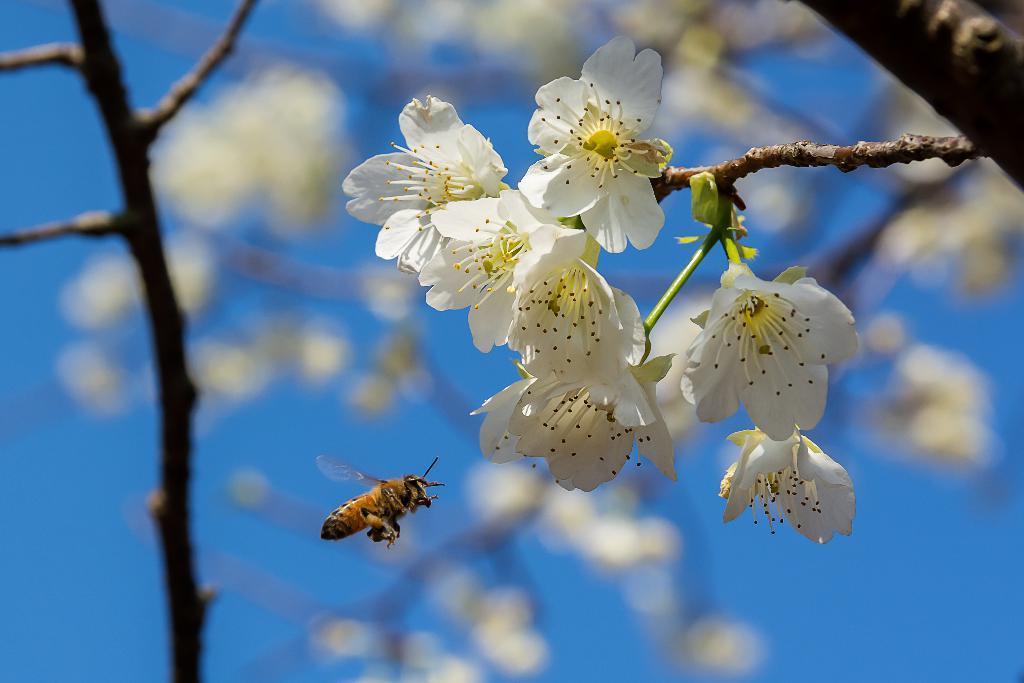Please provide a concise description of this image. In this image, I can see a bunch of flowers to a stem. I can see an insect flying in the air. The background looks blurry. 